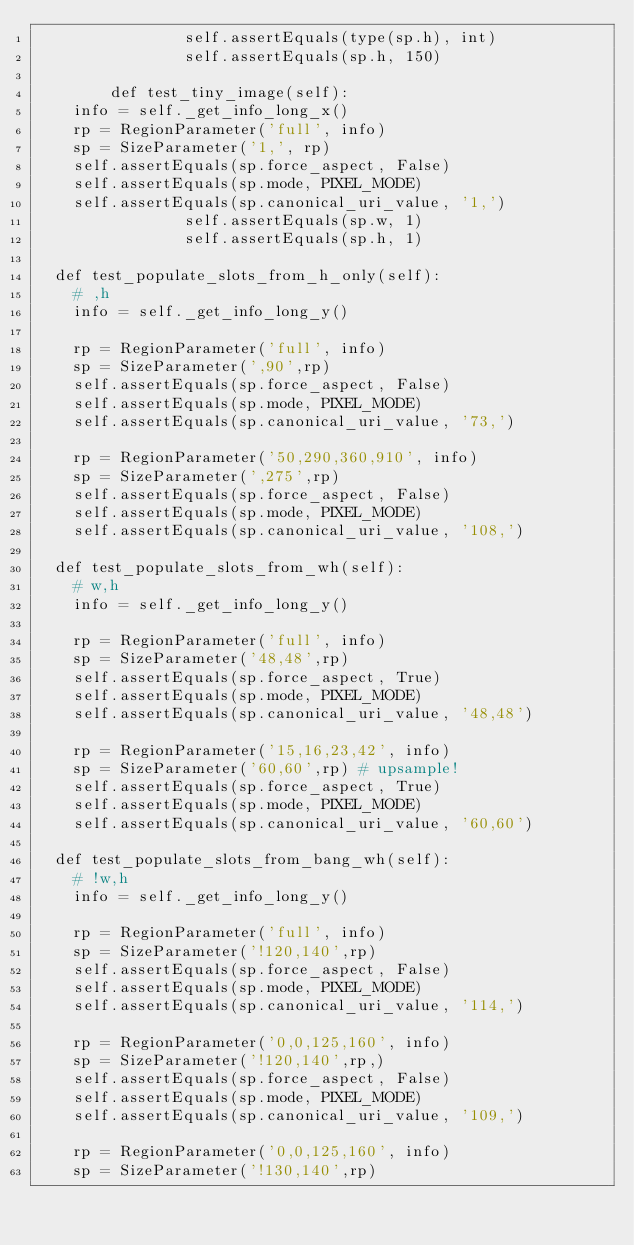Convert code to text. <code><loc_0><loc_0><loc_500><loc_500><_Python_>                self.assertEquals(type(sp.h), int)
                self.assertEquals(sp.h, 150)

        def test_tiny_image(self):
		info = self._get_info_long_x()
		rp = RegionParameter('full', info)
		sp = SizeParameter('1,', rp)
		self.assertEquals(sp.force_aspect, False)
		self.assertEquals(sp.mode, PIXEL_MODE)
		self.assertEquals(sp.canonical_uri_value, '1,')
                self.assertEquals(sp.w, 1)
                self.assertEquals(sp.h, 1)

	def test_populate_slots_from_h_only(self):
		# ,h
		info = self._get_info_long_y()

		rp = RegionParameter('full', info)
		sp = SizeParameter(',90',rp)
		self.assertEquals(sp.force_aspect, False)
		self.assertEquals(sp.mode, PIXEL_MODE)
		self.assertEquals(sp.canonical_uri_value, '73,')

		rp = RegionParameter('50,290,360,910', info)
		sp = SizeParameter(',275',rp)
		self.assertEquals(sp.force_aspect, False)
		self.assertEquals(sp.mode, PIXEL_MODE)
		self.assertEquals(sp.canonical_uri_value, '108,')

	def test_populate_slots_from_wh(self):
		# w,h
		info = self._get_info_long_y()

		rp = RegionParameter('full', info)
		sp = SizeParameter('48,48',rp)
		self.assertEquals(sp.force_aspect, True)
		self.assertEquals(sp.mode, PIXEL_MODE)
		self.assertEquals(sp.canonical_uri_value, '48,48')

		rp = RegionParameter('15,16,23,42', info)
		sp = SizeParameter('60,60',rp) # upsample!
		self.assertEquals(sp.force_aspect, True)
		self.assertEquals(sp.mode, PIXEL_MODE)
		self.assertEquals(sp.canonical_uri_value, '60,60')

	def test_populate_slots_from_bang_wh(self):
		# !w,h
		info = self._get_info_long_y()

		rp = RegionParameter('full', info)
		sp = SizeParameter('!120,140',rp)
		self.assertEquals(sp.force_aspect, False)
		self.assertEquals(sp.mode, PIXEL_MODE)
		self.assertEquals(sp.canonical_uri_value, '114,')

		rp = RegionParameter('0,0,125,160', info)
		sp = SizeParameter('!120,140',rp,)
		self.assertEquals(sp.force_aspect, False)
		self.assertEquals(sp.mode, PIXEL_MODE)
		self.assertEquals(sp.canonical_uri_value, '109,')

		rp = RegionParameter('0,0,125,160', info)
		sp = SizeParameter('!130,140',rp)</code> 